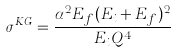<formula> <loc_0><loc_0><loc_500><loc_500>\sigma ^ { K G } = \frac { \alpha ^ { 2 } E _ { f } ( E _ { i } + E _ { f } ) ^ { 2 } } { E _ { i } { Q } ^ { 4 } }</formula> 